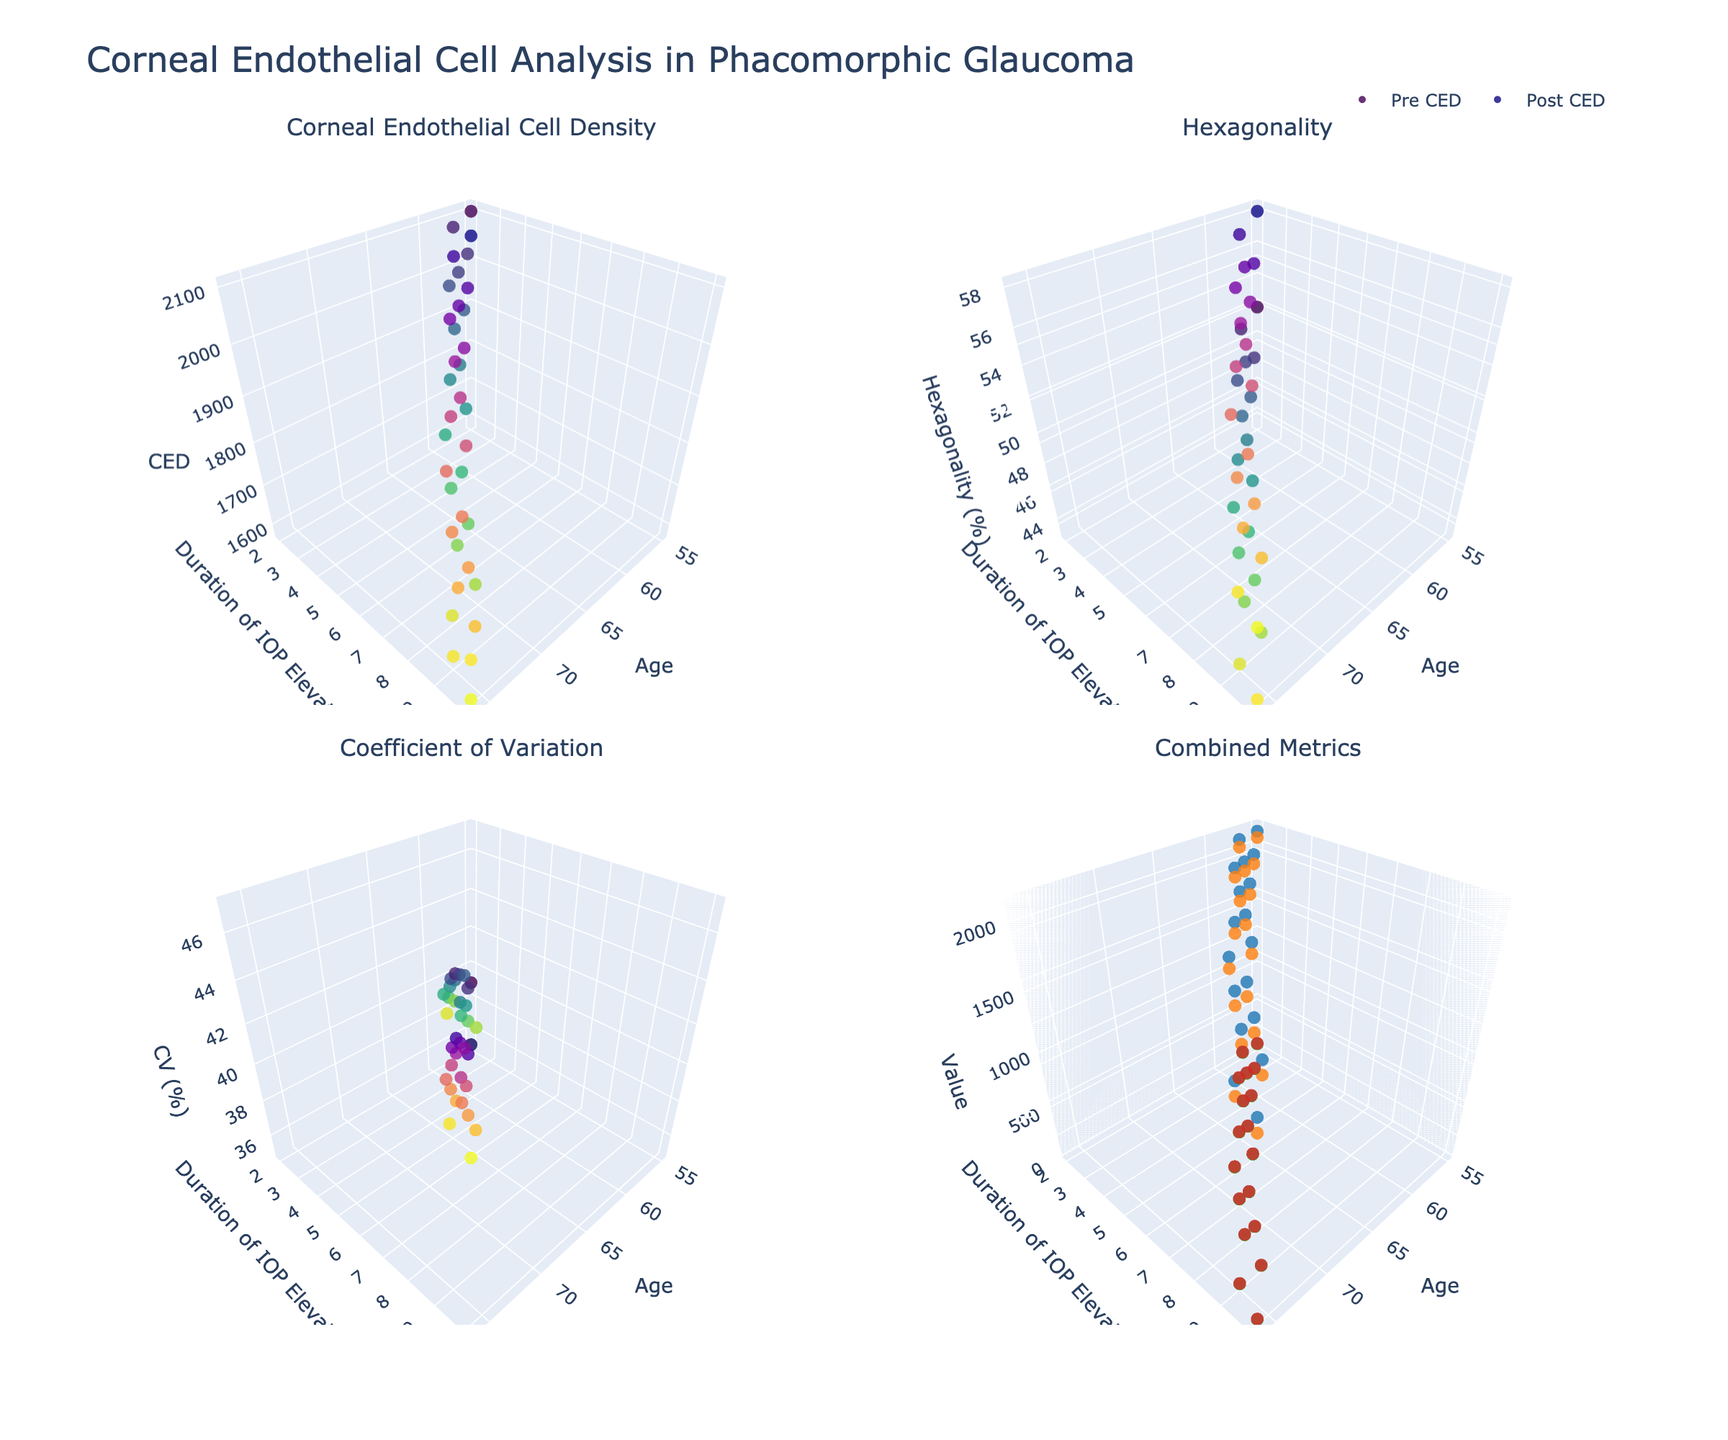What is the title of the figure? The title of the figure is usually located at the top of the image. By referring to the subplot's main title, one can see that it is "Corneal Endothelial Cell Analysis in Phacomorphic Glaucoma."
Answer: Corneal Endothelial Cell Analysis in Phacomorphic Glaucoma How many subplots are present in the figure? By observing the figure, you can count the number of 3D subplots. There are four subplots arranged in a grid of 2 rows and 2 columns.
Answer: Four What is the x-axis labeled in each subplot? All subplots share the same x-axis, which is labeled as "Age." This can be seen by looking at the axis label on each subplot.
Answer: Age Which color scale is used for Pre-surgery markers in the CED subplot? The Pre-surgery markers in the CED subplot use the 'Viridis' color scale. This information can be identified by looking at the colors of the data points and the legend.
Answer: Viridis What's the range of age values shown in the figure? By observing the x-axis across all subplots, one can note the minimum and maximum age values. These range from 55 to 76 years.
Answer: 55 to 76 What is the main trend observed in corneal endothelial cell density (CED) after surgery as age increases? Observing the subplot for CED, notice the pattern of Post_CED markers as age increases. As age increases, there is a general trend of decreasing Post_CED values.
Answer: Decreasing How does the duration of elevated IOP influence Post-CV values in older patients (age > 70)? Look at the subplot for CV and focus on the data points where age > 70. As the duration of elevated IOP increases, Post-CV values generally increase.
Answer: Increase Compare the pre- and post-surgery hexagonality for a patient aged 62 with a duration of elevated IOP of 4 days. Locate the markers for age 62 and duration IOP elevation of 4 days in the Hexagonality subplot. Note the Pre and Post values. Pre-surgery hexagonality is 48%, and post-surgery is 54%.
Answer: 48%, 54% In the "Combined Metrics" subplot, which metric appears to have the most noticeable difference between pre and post-surgery measurements? By observing the markers corresponding to different metrics in the combined subplot, notice the differences. Hexagonality seems to show a noticeable change from Pre (green) to Post (red) markers.
Answer: Hexagonality What's the correlation between duration of IOP elevation and coefficient of variation (CV) before surgery? Observe the subplot related to CV and note the trend in Pre-CV markers as the duration of IOP elevation increases. There is a positive correlation where higher durations correspond to higher Pre-CV values.
Answer: Positive correlation 